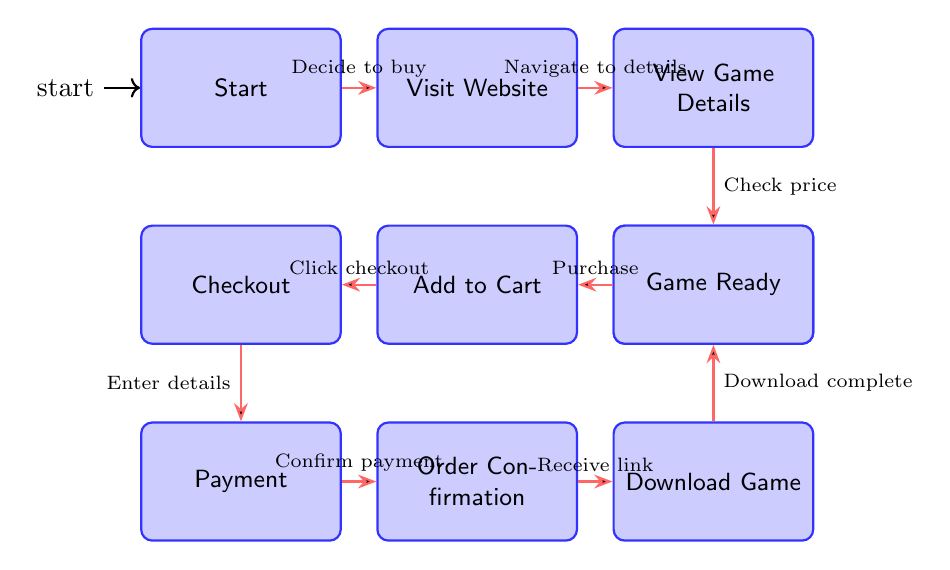What's the starting state of the diagram? The starting state is labeled "Start," which indicates before the user begins the purchasing process.
Answer: Start How many nodes are there in the diagram? Counting the states in the diagram, we have ten distinct states, which represent the stages in the user journey for buying a new Halo game online.
Answer: 10 What is the transition trigger between "Visit Website" and "View Game Details"? The transition from "Visit Website" to "View Game Details" occurs when the user navigates to the details page of the game.
Answer: Navigate to details From which state does the "Payment" state transition? The "Payment" state transitions from the "Checkout" state, where the user enters shipping and payment details before confirming the purchase.
Answer: Checkout What is the final state the user reaches after "Download Game"? After the "Download Game" state, the next and final state the user reaches is the "Game Ready" stage, signifying that the game is now ready for play.
Answer: Game Ready What triggers the transition from "Order Confirmation" to "Download Game"? The transition from "Order Confirmation" to "Download Game" is triggered when the user receives confirmation and a download link or information regarding shipping.
Answer: Receive link Which state does the user enter after "Check Price & Availability"? After "Check Price & Availability," the user proceeds to the "Add to Cart" state, which indicates their decision to purchase the game.
Answer: Add to Cart How many transitions are shown in the diagram? There are nine transitions depicted in the diagram, illustrating the flow from one state to another throughout the purchasing process.
Answer: 9 What is the trigger for transitioning from "Add to Cart" to "Checkout"? The trigger that moves the user from the "Add to Cart" state to the "Checkout" state is when the user clicks on the checkout button.
Answer: Click checkout 